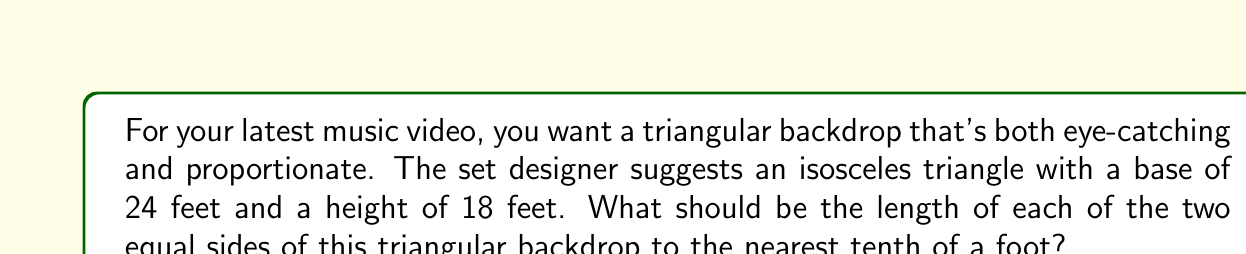Help me with this question. Let's approach this step-by-step:

1) We're dealing with an isosceles triangle where:
   - The base (b) is 24 feet
   - The height (h) is 18 feet
   - We need to find the length of the equal sides (let's call this s)

2) We can split this isosceles triangle into two right triangles. In each of these right triangles:
   - The height (18 feet) forms one leg
   - Half of the base (12 feet) forms the other leg
   - The side we're looking for (s) forms the hypotenuse

3) We can use the Pythagorean theorem to find s:

   $$s^2 = (\frac{b}{2})^2 + h^2$$

4) Substituting our known values:

   $$s^2 = 12^2 + 18^2$$

5) Simplify:

   $$s^2 = 144 + 324 = 468$$

6) Take the square root of both sides:

   $$s = \sqrt{468}$$

7) Simplify the square root:

   $$s = 6\sqrt{13} \approx 21.633$$

8) Rounding to the nearest tenth:

   $$s \approx 21.6\text{ feet}$$

[asy]
import geometry;

size(200);

pair A = (0,0), B = (24,0), C = (12,18);

draw(A--B--C--cycle);
draw(B--C,dashed);

label("24'", (12,-0.5), S);
label("18'", (24.5,9), E);
label("s", (6,10), NW);
label("s", (18,10), NE);

dot("A", A, SW);
dot("B", B, SE);
dot("C", C, N);
[/asy]
Answer: 21.6 feet 